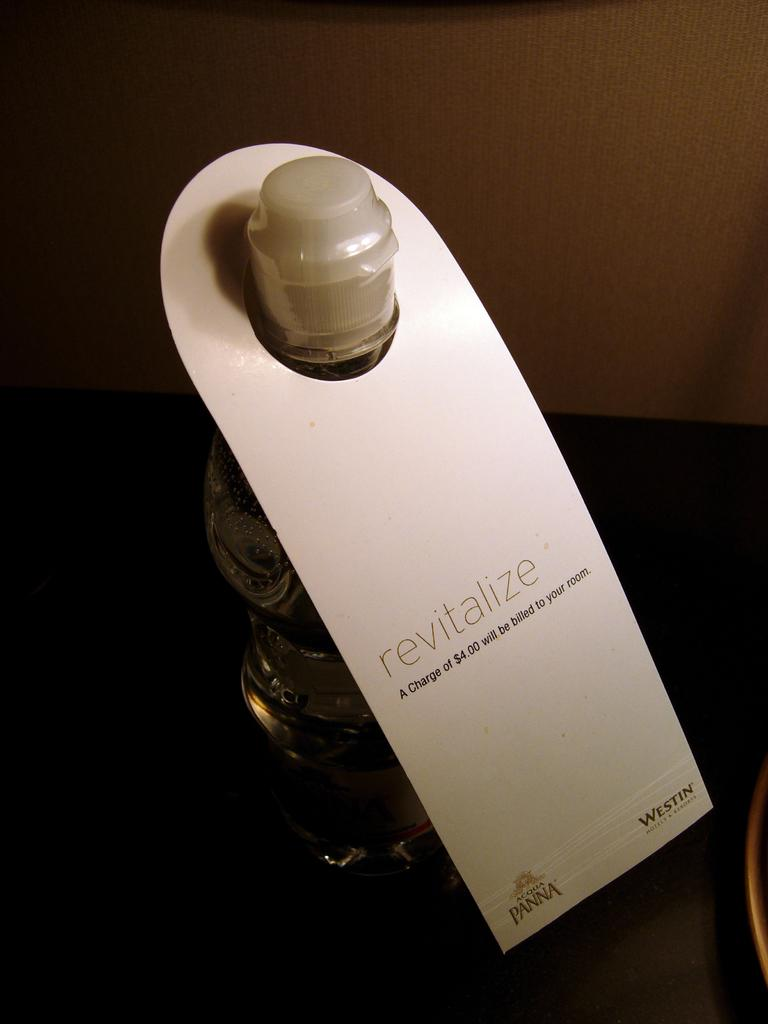<image>
Render a clear and concise summary of the photo. The sign states a charge of $4.00 will be billed to your room if you drink the beverage. 